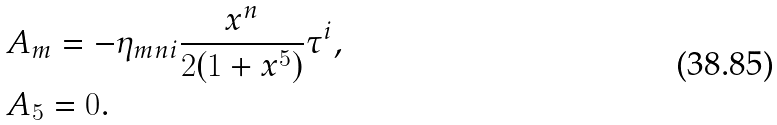Convert formula to latex. <formula><loc_0><loc_0><loc_500><loc_500>& A _ { m } = - \eta _ { m n i } \frac { x ^ { n } } { 2 ( 1 + x ^ { 5 } ) } \tau ^ { i } , \\ & A _ { 5 } = 0 .</formula> 